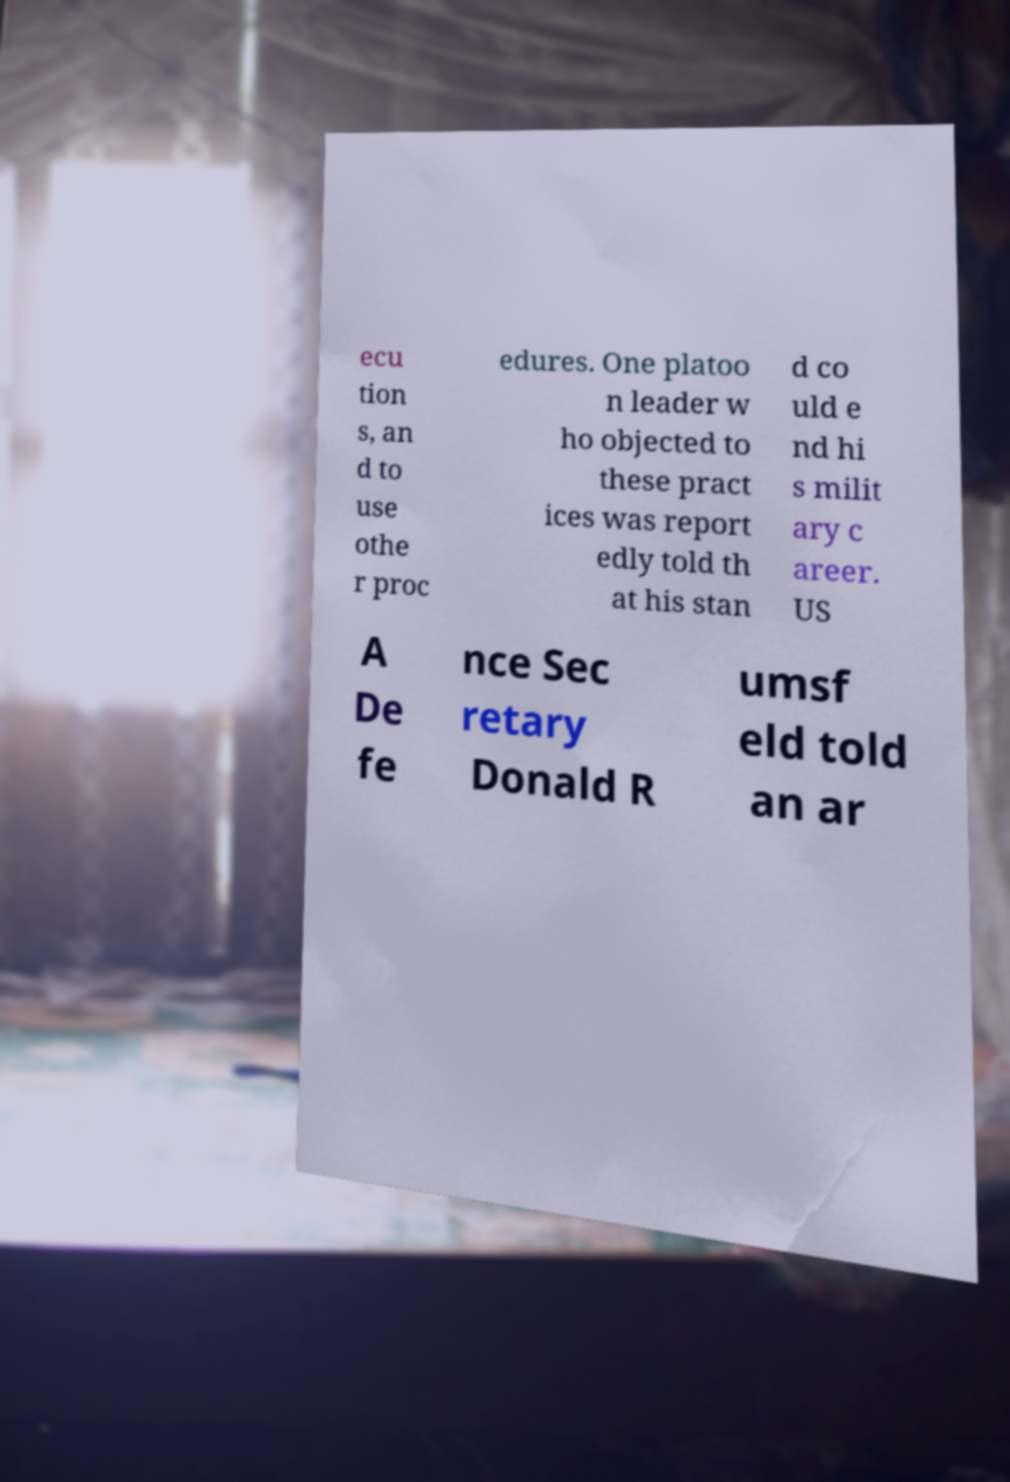Please identify and transcribe the text found in this image. ecu tion s, an d to use othe r proc edures. One platoo n leader w ho objected to these pract ices was report edly told th at his stan d co uld e nd hi s milit ary c areer. US A De fe nce Sec retary Donald R umsf eld told an ar 